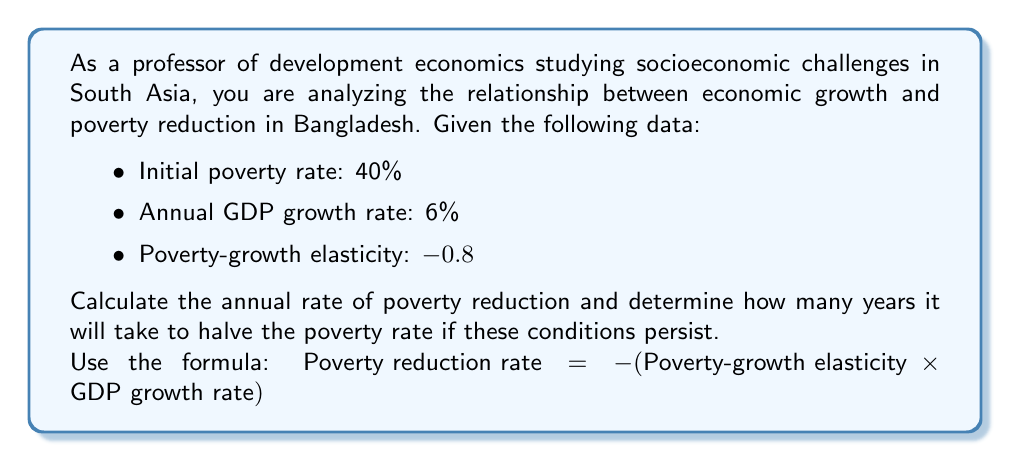Can you solve this math problem? To solve this problem, we'll follow these steps:

1. Calculate the annual poverty reduction rate:
   $$\text{Poverty reduction rate} = -(\text{Poverty-growth elasticity} \times \text{GDP growth rate})$$
   $$= -((-0.8) \times 6\%)$$
   $$= 0.8 \times 6\% = 4.8\%$$

2. To find how long it will take to halve the poverty rate, we need to determine when the poverty rate reaches 20% (half of 40%):
   Let $t$ be the number of years, and $P_t$ be the poverty rate after $t$ years.
   $$P_t = P_0 \times (1 - r)^t$$
   Where $P_0$ is the initial poverty rate (40%), and $r$ is the annual poverty reduction rate (4.8% or 0.048).

3. We want to solve for $t$ when $P_t = 20\%$:
   $$20\% = 40\% \times (1 - 0.048)^t$$

4. Divide both sides by 40%:
   $$0.5 = (1 - 0.048)^t$$

5. Take the natural log of both sides:
   $$\ln(0.5) = t \times \ln(1 - 0.048)$$

6. Solve for $t$:
   $$t = \frac{\ln(0.5)}{\ln(1 - 0.048)} \approx 14.78$$

Therefore, it will take approximately 14.78 years to halve the poverty rate.
Answer: The annual poverty reduction rate is 4.8%, and it will take approximately 14.78 years to halve the poverty rate from 40% to 20% under the given conditions. 